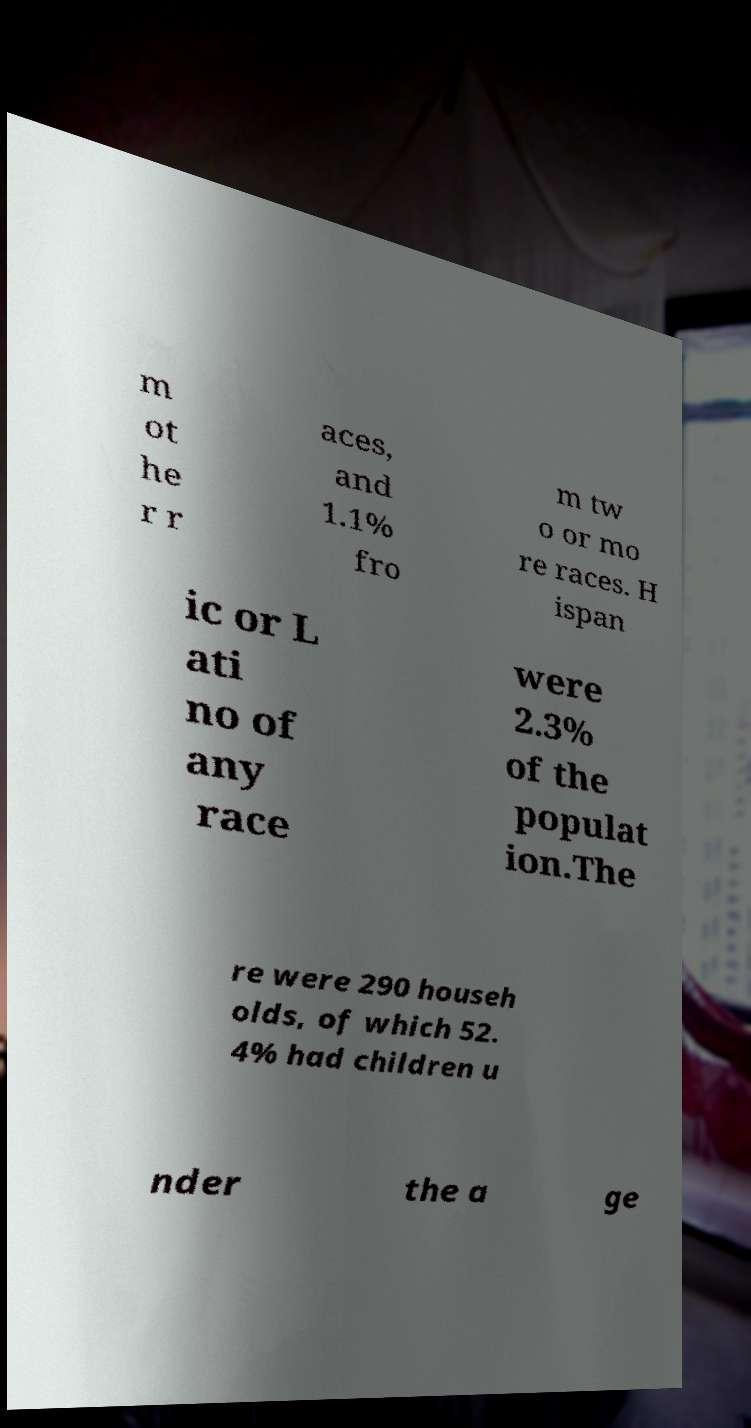For documentation purposes, I need the text within this image transcribed. Could you provide that? m ot he r r aces, and 1.1% fro m tw o or mo re races. H ispan ic or L ati no of any race were 2.3% of the populat ion.The re were 290 househ olds, of which 52. 4% had children u nder the a ge 